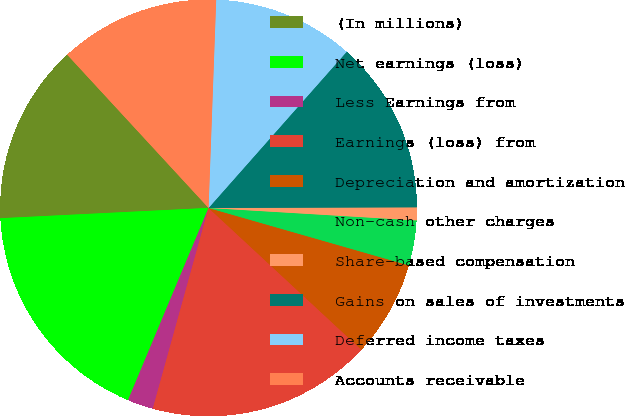Convert chart. <chart><loc_0><loc_0><loc_500><loc_500><pie_chart><fcel>(In millions)<fcel>Net earnings (loss)<fcel>Less Earnings from<fcel>Earnings (loss) from<fcel>Depreciation and amortization<fcel>Non-cash other charges<fcel>Share-based compensation<fcel>Gains on sales of investments<fcel>Deferred income taxes<fcel>Accounts receivable<nl><fcel>13.93%<fcel>17.9%<fcel>2.0%<fcel>17.41%<fcel>7.46%<fcel>3.49%<fcel>1.0%<fcel>13.43%<fcel>10.94%<fcel>12.44%<nl></chart> 